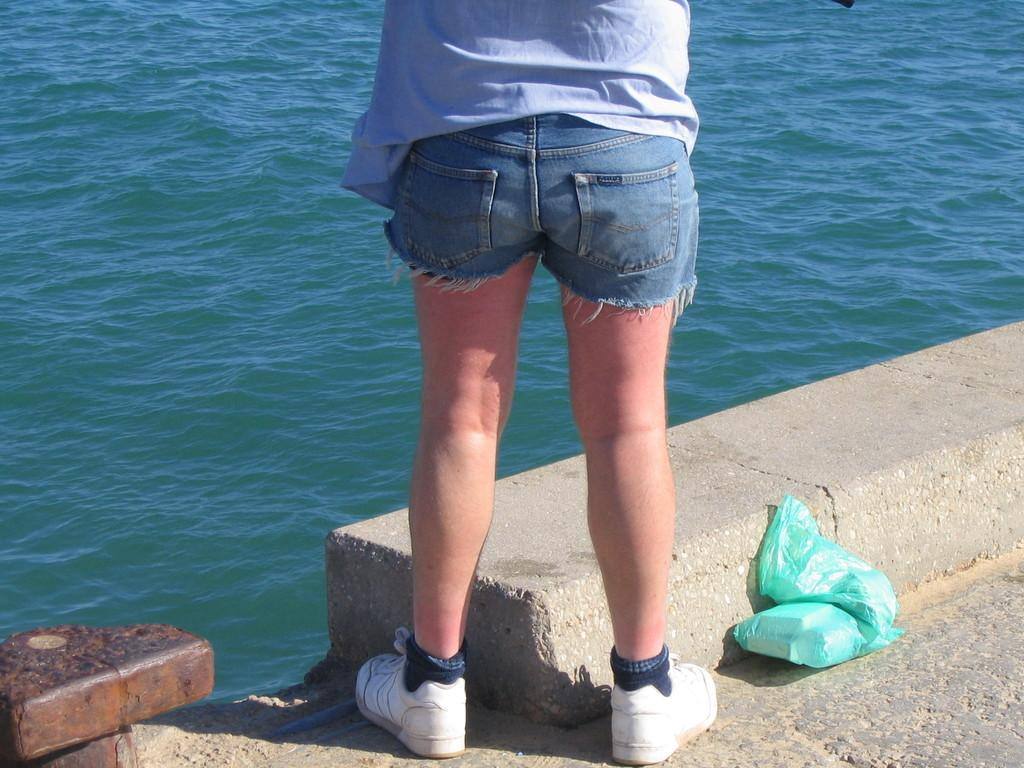What is the person in the image wearing? The person is wearing a shirt, shorts, socks, and shoes. What color is the polythene bag in the image? The polythene bag in the image is green. What is happening in the image involving water? Water is flowing in the image. How many snakes are slithering around the person's feet in the image? There are no snakes present in the image. What is the relation between the person and the ice in the image? There is no ice present in the image, so there is no relation between the person and ice. 